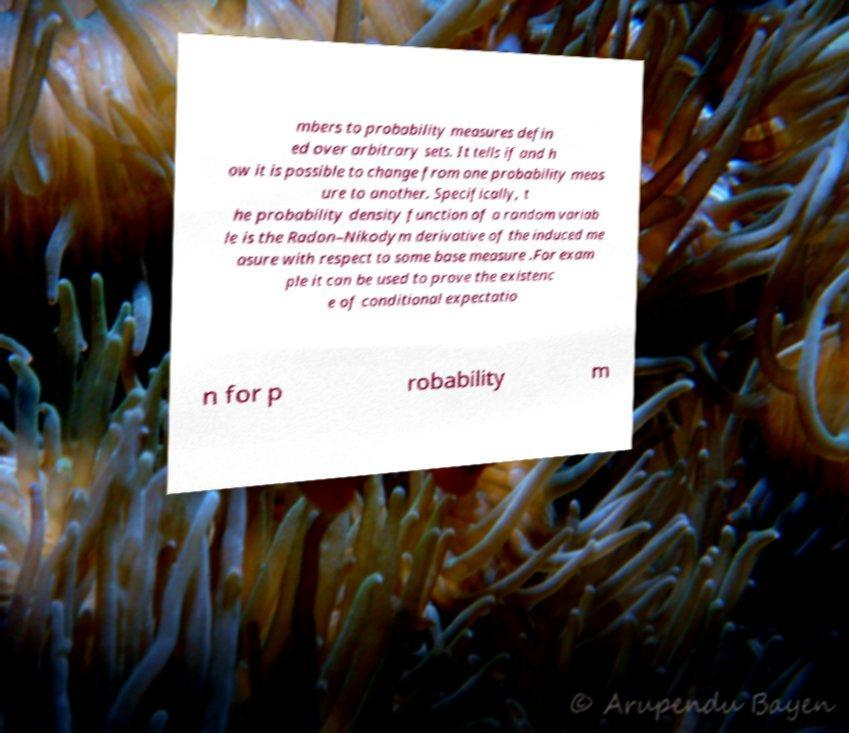Please identify and transcribe the text found in this image. mbers to probability measures defin ed over arbitrary sets. It tells if and h ow it is possible to change from one probability meas ure to another. Specifically, t he probability density function of a random variab le is the Radon–Nikodym derivative of the induced me asure with respect to some base measure .For exam ple it can be used to prove the existenc e of conditional expectatio n for p robability m 